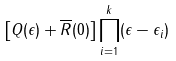Convert formula to latex. <formula><loc_0><loc_0><loc_500><loc_500>\left [ Q ( \epsilon ) + \overline { R } ( 0 ) \right ] \prod _ { i = 1 } ^ { k } ( \epsilon - \epsilon _ { i } )</formula> 